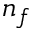Convert formula to latex. <formula><loc_0><loc_0><loc_500><loc_500>n _ { f }</formula> 